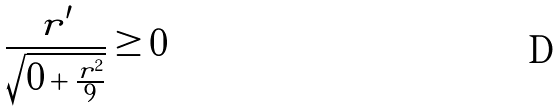<formula> <loc_0><loc_0><loc_500><loc_500>\frac { r ^ { \prime } } { \sqrt { 0 + \frac { r ^ { 2 } } { 9 } } } \geq 0</formula> 